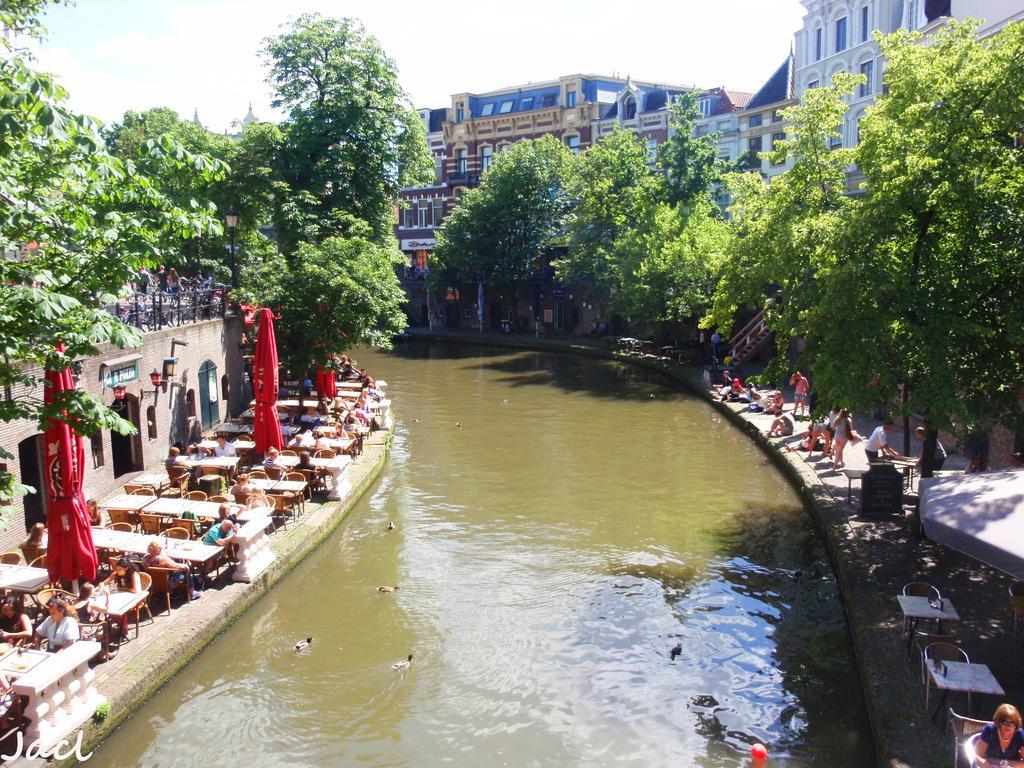Please provide a concise description of this image. There are people sitting around the tables and water in the foreground area of the image, there are trees, buildings and the sky in the background. 